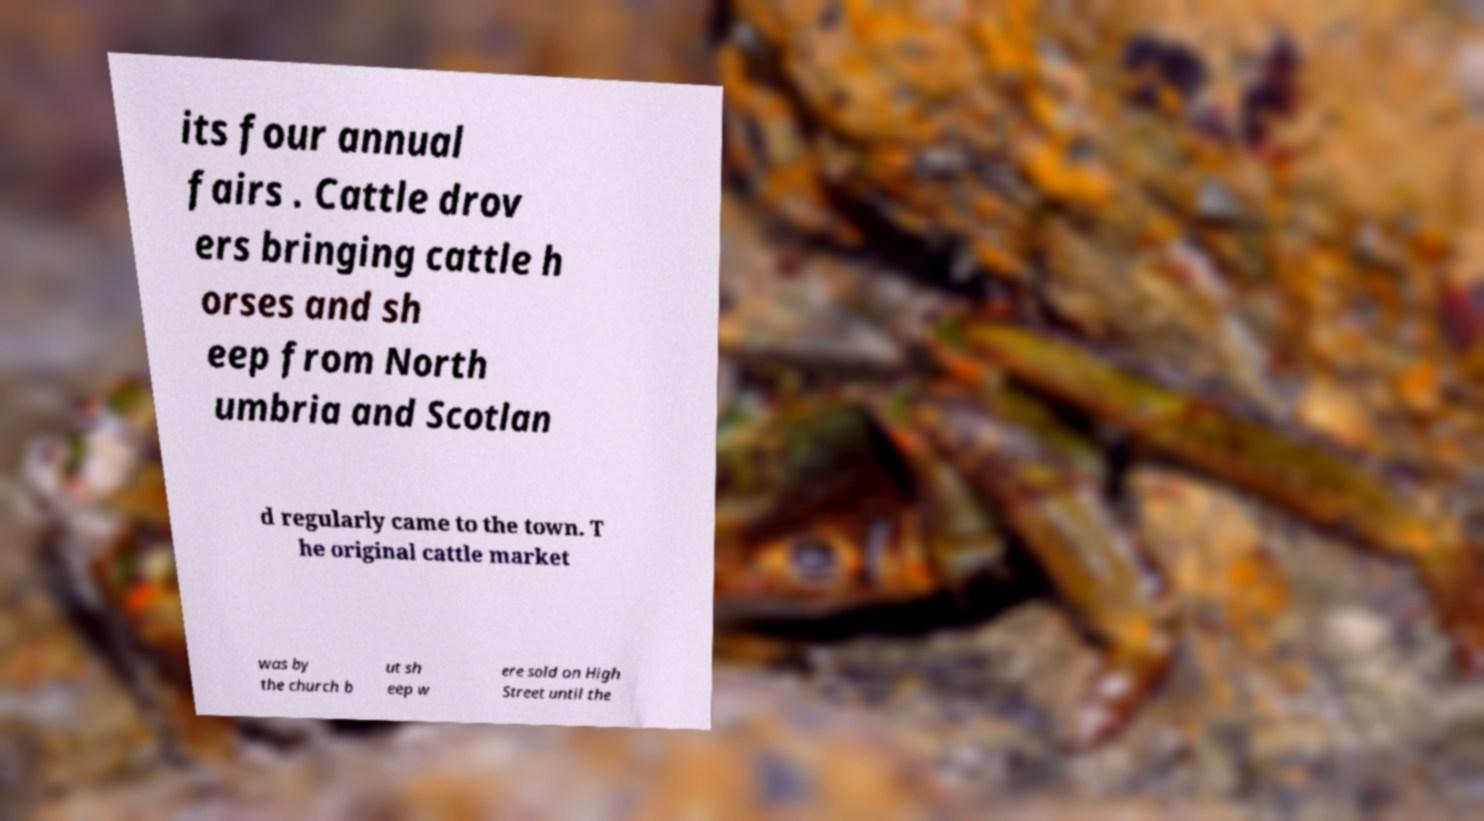Could you extract and type out the text from this image? its four annual fairs . Cattle drov ers bringing cattle h orses and sh eep from North umbria and Scotlan d regularly came to the town. T he original cattle market was by the church b ut sh eep w ere sold on High Street until the 